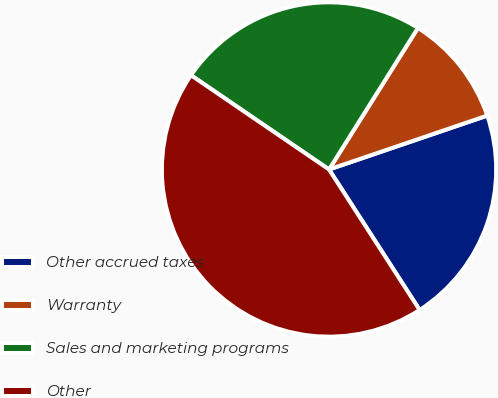<chart> <loc_0><loc_0><loc_500><loc_500><pie_chart><fcel>Other accrued taxes<fcel>Warranty<fcel>Sales and marketing programs<fcel>Other<nl><fcel>21.11%<fcel>10.85%<fcel>24.39%<fcel>43.65%<nl></chart> 